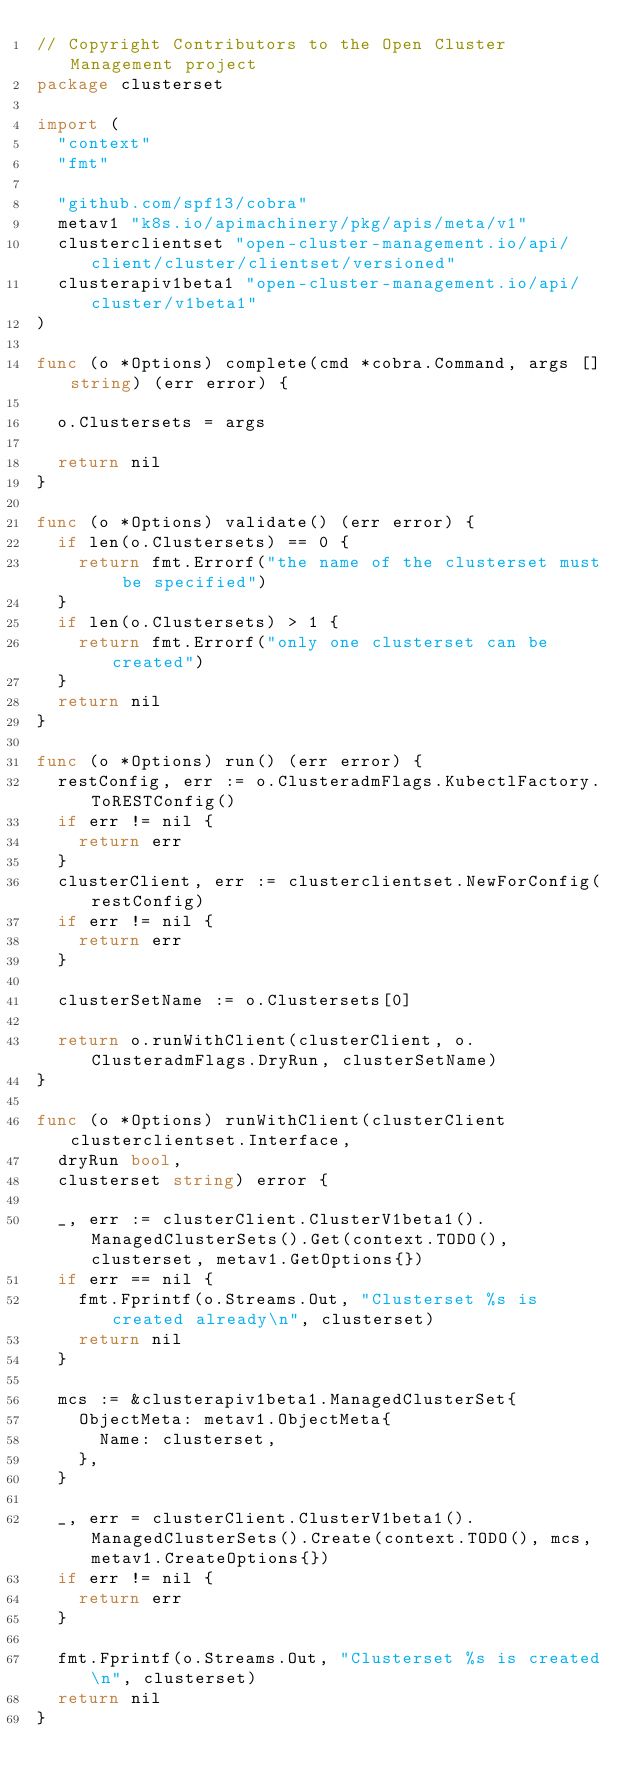Convert code to text. <code><loc_0><loc_0><loc_500><loc_500><_Go_>// Copyright Contributors to the Open Cluster Management project
package clusterset

import (
	"context"
	"fmt"

	"github.com/spf13/cobra"
	metav1 "k8s.io/apimachinery/pkg/apis/meta/v1"
	clusterclientset "open-cluster-management.io/api/client/cluster/clientset/versioned"
	clusterapiv1beta1 "open-cluster-management.io/api/cluster/v1beta1"
)

func (o *Options) complete(cmd *cobra.Command, args []string) (err error) {

	o.Clustersets = args

	return nil
}

func (o *Options) validate() (err error) {
	if len(o.Clustersets) == 0 {
		return fmt.Errorf("the name of the clusterset must be specified")
	}
	if len(o.Clustersets) > 1 {
		return fmt.Errorf("only one clusterset can be created")
	}
	return nil
}

func (o *Options) run() (err error) {
	restConfig, err := o.ClusteradmFlags.KubectlFactory.ToRESTConfig()
	if err != nil {
		return err
	}
	clusterClient, err := clusterclientset.NewForConfig(restConfig)
	if err != nil {
		return err
	}

	clusterSetName := o.Clustersets[0]

	return o.runWithClient(clusterClient, o.ClusteradmFlags.DryRun, clusterSetName)
}

func (o *Options) runWithClient(clusterClient clusterclientset.Interface,
	dryRun bool,
	clusterset string) error {

	_, err := clusterClient.ClusterV1beta1().ManagedClusterSets().Get(context.TODO(), clusterset, metav1.GetOptions{})
	if err == nil {
		fmt.Fprintf(o.Streams.Out, "Clusterset %s is created already\n", clusterset)
		return nil
	}

	mcs := &clusterapiv1beta1.ManagedClusterSet{
		ObjectMeta: metav1.ObjectMeta{
			Name: clusterset,
		},
	}

	_, err = clusterClient.ClusterV1beta1().ManagedClusterSets().Create(context.TODO(), mcs, metav1.CreateOptions{})
	if err != nil {
		return err
	}

	fmt.Fprintf(o.Streams.Out, "Clusterset %s is created\n", clusterset)
	return nil
}
</code> 